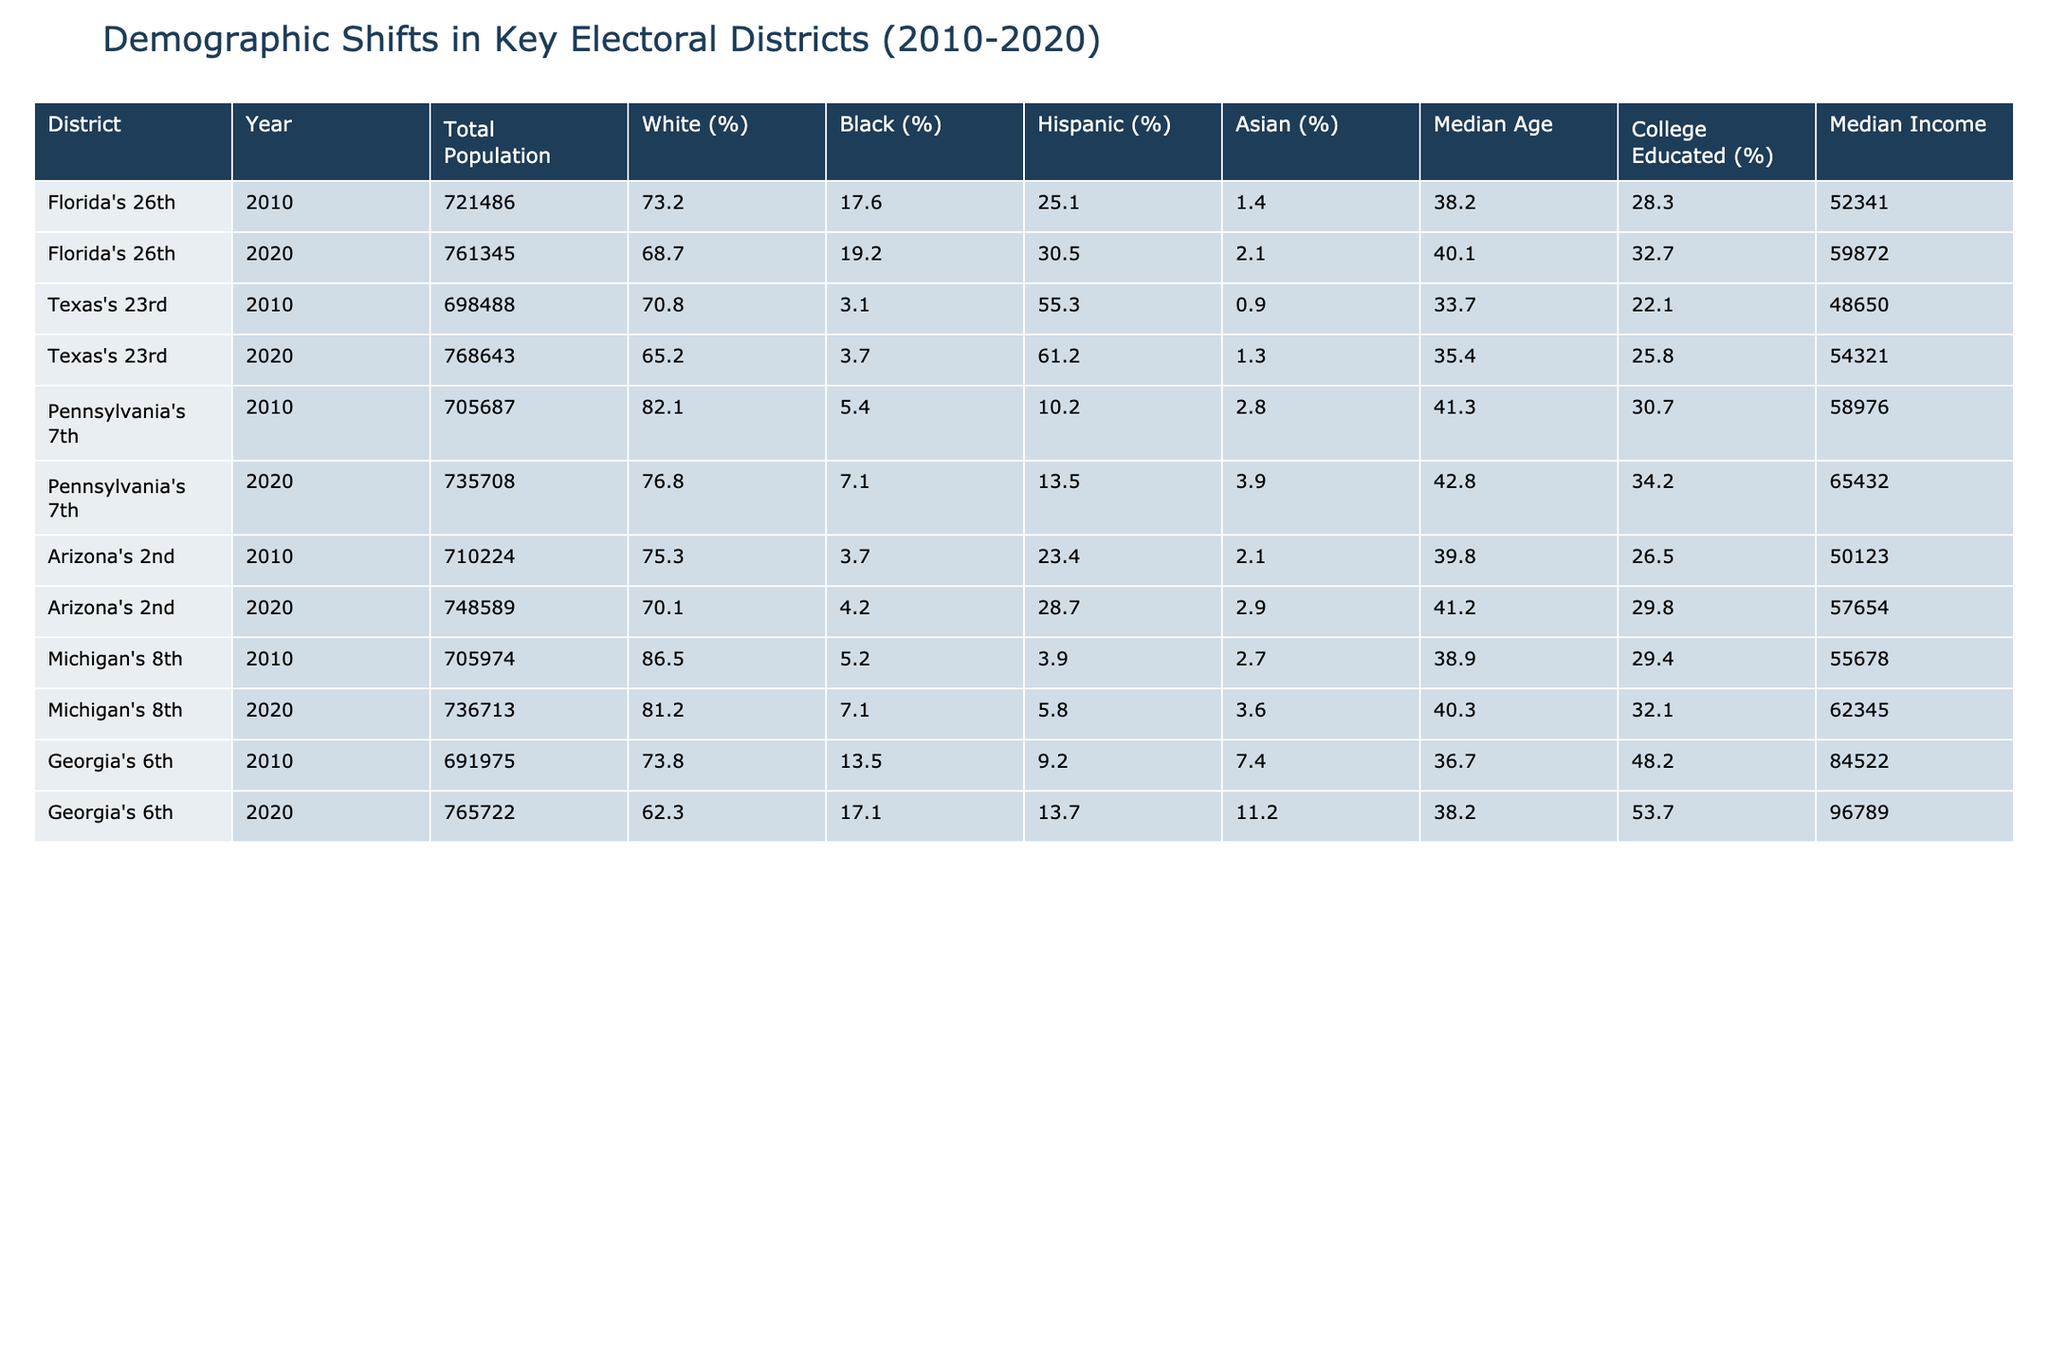What was the median income in Florida's 26th district in 2020? The table shows the median income for Florida's 26th district in 2020 as $59,872.
Answer: $59,872 What percentage of the population in Pennsylvania's 7th district was Black in 2010? According to the table, the percentage of the Black population in Pennsylvania's 7th district in 2010 was 5.4%.
Answer: 5.4% Which district saw the largest increase in the Hispanic population percentage from 2010 to 2020? By looking at the table, the Hispanic population percentage in Texas's 23rd district increased from 55.3% in 2010 to 61.2% in 2020. The change is 61.2% - 55.3% = 5.9%. Thus, Texas's 23rd district had the largest increase.
Answer: Texas's 23rd What was the change in the total population of Arizona's 2nd district from 2010 to 2020? The total population for Arizona's 2nd district in 2010 was 710,224 and in 2020 was 748,589. The change is calculated by subtracting: 748,589 - 710,224 = 38,365.
Answer: 38,365 Which district had the highest percentage of college-educated individuals in 2020? Looking across the table for the years listed, Georgia's 6th district has the highest percentage of college-educated individuals in 2020 at 53.7%.
Answer: 53.7% Did Florida's 26th district experience a decrease in the percentage of White individuals from 2010 to 2020? In Florida's 26th district, the percentage of White individuals decreased from 73.2% in 2010 to 68.7% in 2020; therefore, it's true.
Answer: Yes What is the average median age of the districts in 2020? The median ages for the districts in 2020 are 40.1 (Florida's 26th), 35.4 (Texas's 23rd), 42.8 (Pennsylvania's 7th), 41.2 (Arizona's 2nd), 40.3 (Michigan's 8th), and 38.2 (Georgia's 6th). Summing them: 40.1 + 35.4 + 42.8 + 41.2 + 40.3 + 38.2 = 238. Average = 238/6 = 39.67.
Answer: 39.67 Which district had the highest total population in 2020? The total population figures for 2020 show that Georgia's 6th district has the highest population with 765,722 individuals.
Answer: Georgia's 6th How much did the median income change in Pennsylvania's 7th district from 2010 to 2020? In 2010, the median income was $58,976, and in 2020, it was $65,432. The change is calculated as $65,432 - $58,976 = $6,456.
Answer: $6,456 Is the percentage of the Asian population in Texas's 23rd district higher in 2020 than in 2010? The table indicates the percentage of the Asian population in Texas's 23rd district is 1.3% in 2020 and 0.9% in 2010, confirming that it has indeed increased.
Answer: Yes 